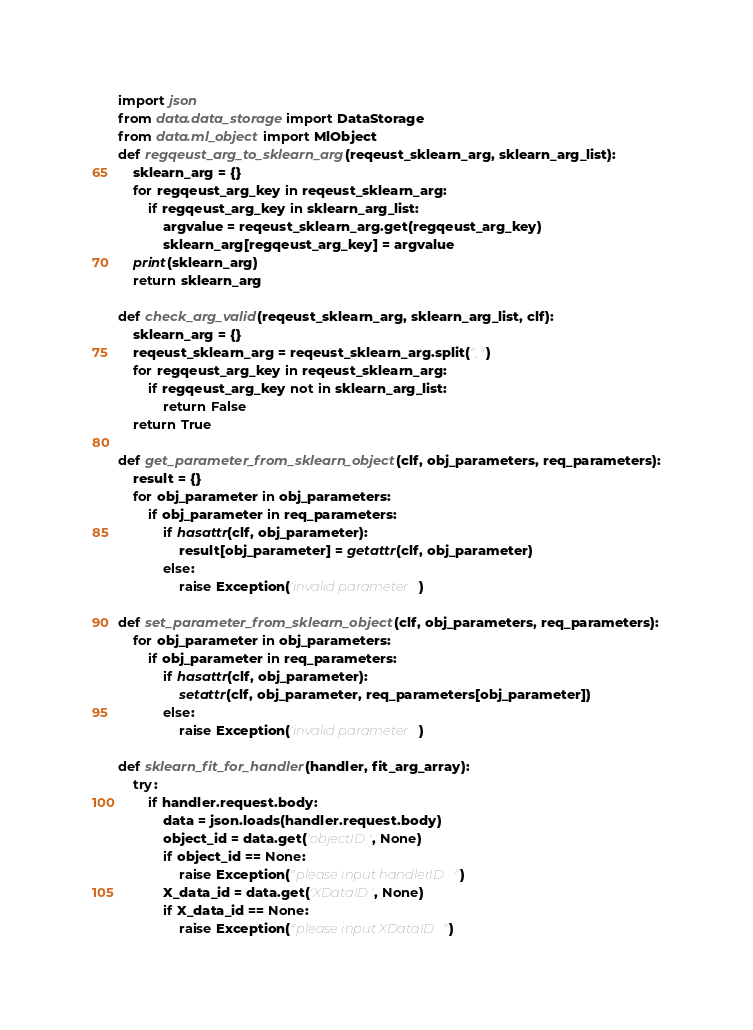<code> <loc_0><loc_0><loc_500><loc_500><_Python_>import json  
from data.data_storage import DataStorage
from data.ml_object import MlObject
def regqeust_arg_to_sklearn_arg(reqeust_sklearn_arg, sklearn_arg_list):
    sklearn_arg = {}
    for regqeust_arg_key in reqeust_sklearn_arg:
        if regqeust_arg_key in sklearn_arg_list:
            argvalue = reqeust_sklearn_arg.get(regqeust_arg_key)
            sklearn_arg[regqeust_arg_key] = argvalue
    print(sklearn_arg)
    return sklearn_arg

def check_arg_valid(reqeust_sklearn_arg, sklearn_arg_list, clf):
    sklearn_arg = {}
    reqeust_sklearn_arg = reqeust_sklearn_arg.split(",")
    for regqeust_arg_key in reqeust_sklearn_arg:
        if regqeust_arg_key not in sklearn_arg_list:
            return False
    return True

def get_parameter_from_sklearn_object(clf, obj_parameters, req_parameters):
    result = {}
    for obj_parameter in obj_parameters:   
        if obj_parameter in req_parameters:
            if hasattr(clf, obj_parameter):
                result[obj_parameter] = getattr(clf, obj_parameter)
            else:
                raise Exception('invalid parameter')

def set_parameter_from_sklearn_object(clf, obj_parameters, req_parameters):
    for obj_parameter in obj_parameters:   
        if obj_parameter in req_parameters:
            if hasattr(clf, obj_parameter):
                setattr(clf, obj_parameter, req_parameters[obj_parameter])
            else:
                raise Exception('invalid parameter')

def sklearn_fit_for_handler(handler, fit_arg_array):
    try:
        if handler.request.body:
            data = json.loads(handler.request.body)
            object_id = data.get('objectID', None)  
            if object_id == None:
                raise Exception("please input handlerID")
            X_data_id = data.get('XDataID', None)
            if X_data_id == None:
                raise Exception("please input XDataID")   </code> 